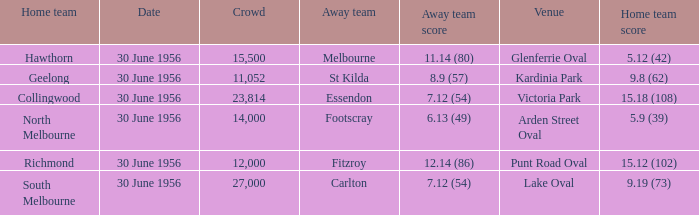What is the home team for punt road oval? Richmond. 